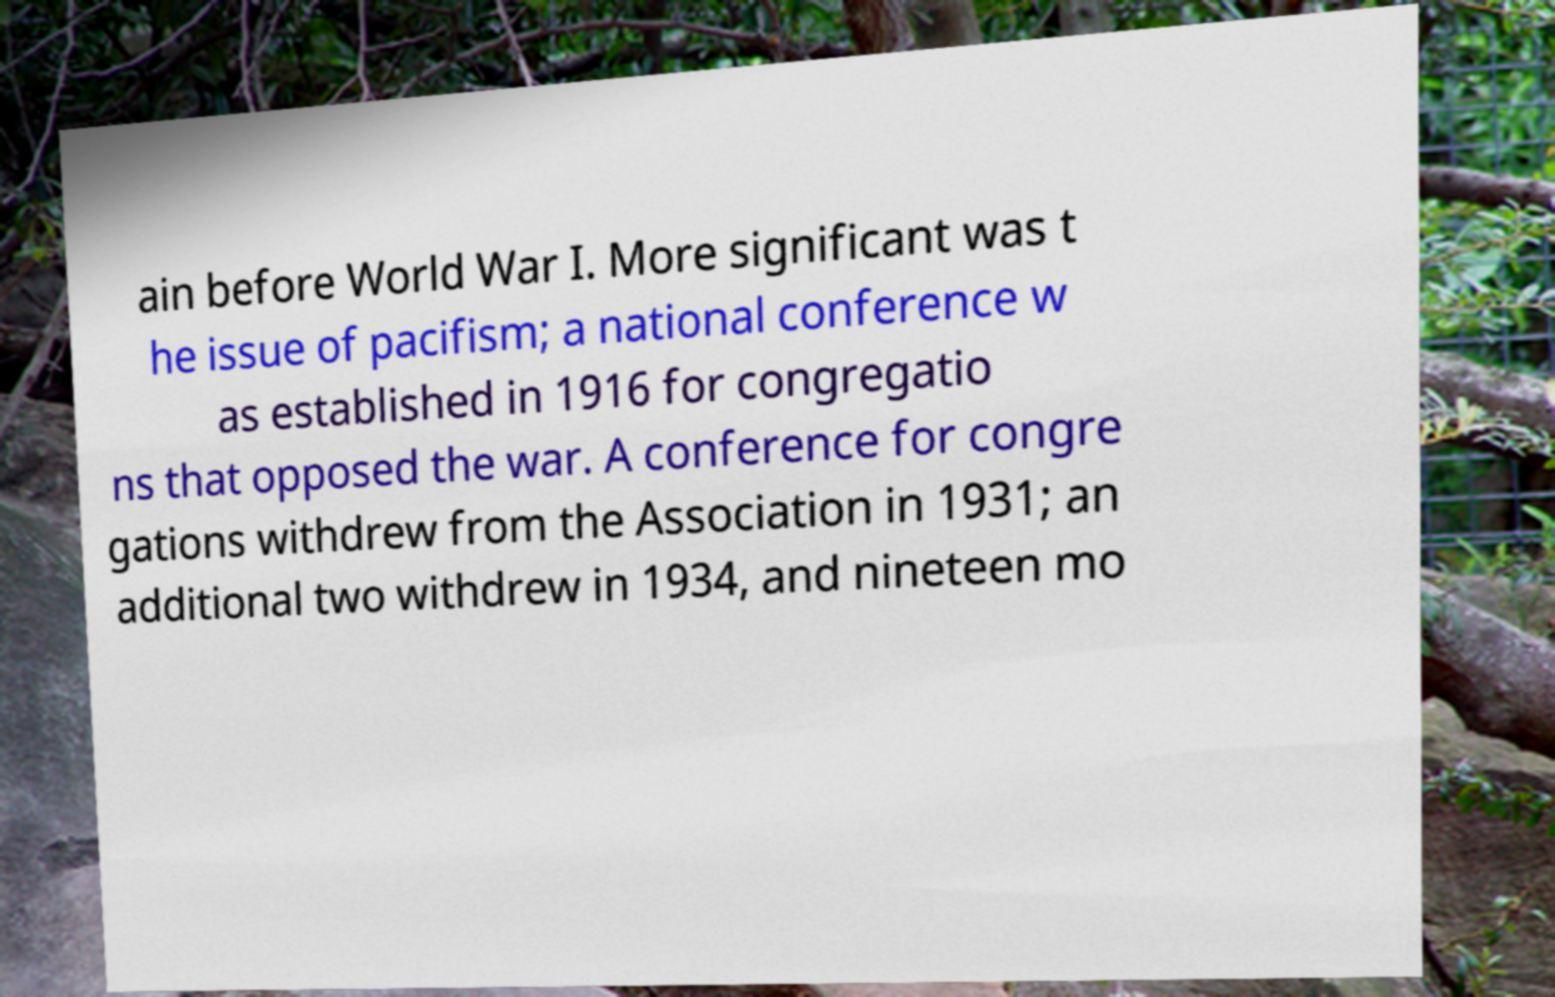Can you accurately transcribe the text from the provided image for me? ain before World War I. More significant was t he issue of pacifism; a national conference w as established in 1916 for congregatio ns that opposed the war. A conference for congre gations withdrew from the Association in 1931; an additional two withdrew in 1934, and nineteen mo 